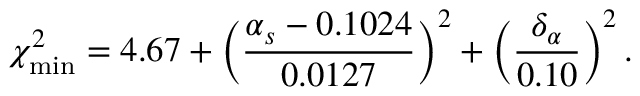Convert formula to latex. <formula><loc_0><loc_0><loc_500><loc_500>\chi _ { \min } ^ { 2 } = 4 . 6 7 + \left ( \frac { \alpha _ { s } - 0 . 1 0 2 4 } { 0 . 0 1 2 7 } \right ) ^ { 2 } + \left ( \frac { \delta _ { \alpha } } { 0 . 1 0 } \right ) ^ { 2 } \, .</formula> 